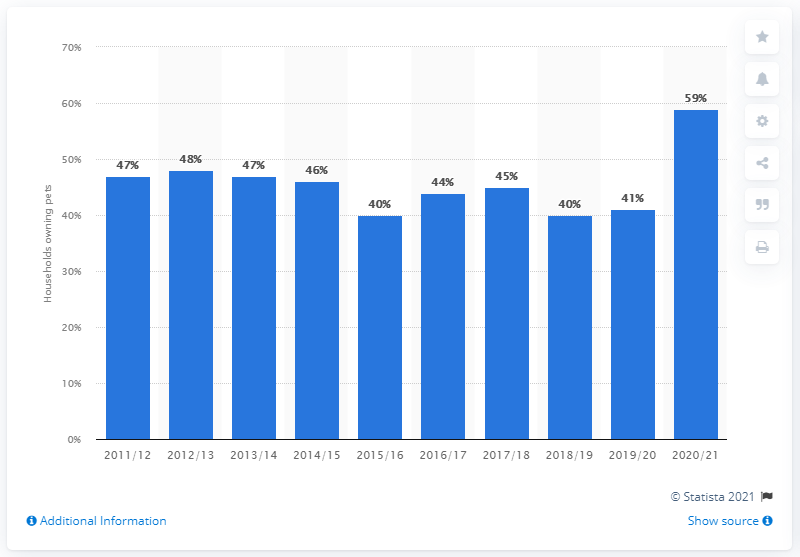Mention a couple of crucial points in this snapshot. The highest percentage of households owning a pet in the UK in 2020/21 was 59%. 